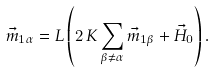Convert formula to latex. <formula><loc_0><loc_0><loc_500><loc_500>\vec { m } _ { 1 \alpha } = L \left ( 2 \, K \sum _ { \beta \neq \alpha } \vec { m } _ { 1 \beta } + \vec { H } _ { 0 } \right ) .</formula> 